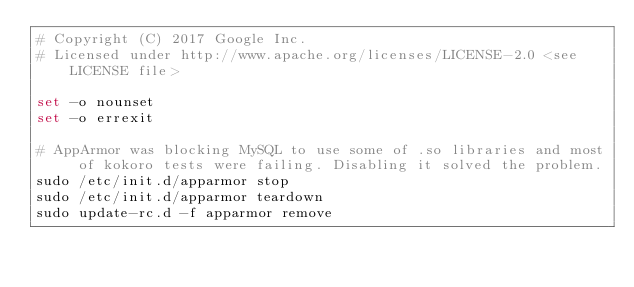Convert code to text. <code><loc_0><loc_0><loc_500><loc_500><_Bash_># Copyright (C) 2017 Google Inc.
# Licensed under http://www.apache.org/licenses/LICENSE-2.0 <see LICENSE file>

set -o nounset
set -o errexit

# AppArmor was blocking MySQL to use some of .so libraries and most of kokoro tests were failing. Disabling it solved the problem.
sudo /etc/init.d/apparmor stop
sudo /etc/init.d/apparmor teardown
sudo update-rc.d -f apparmor remove
</code> 